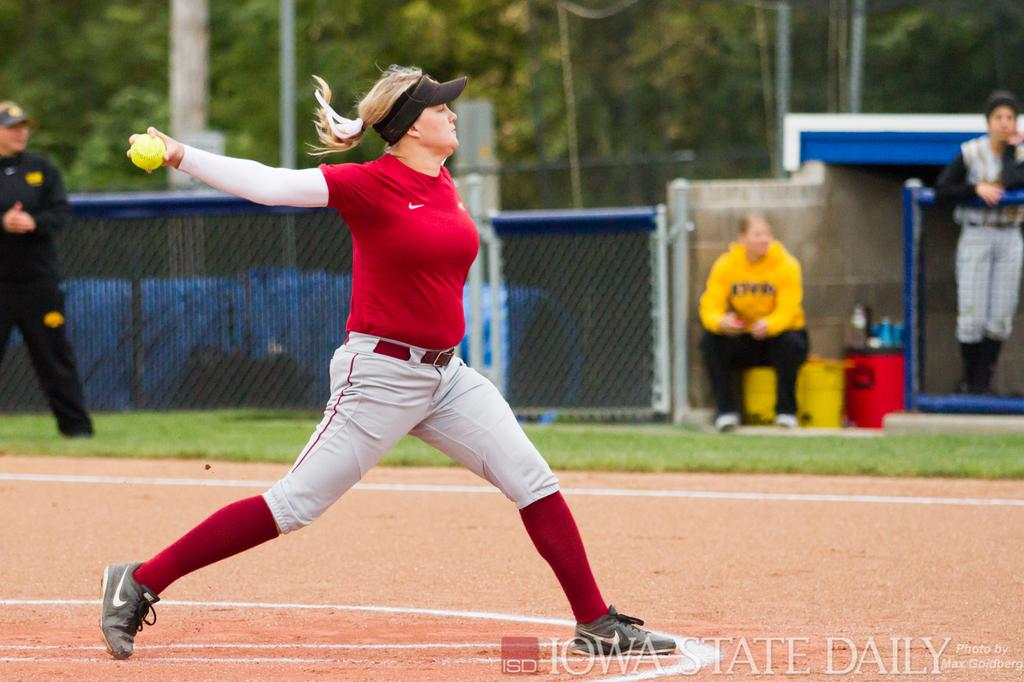Provide a one-sentence caption for the provided image. softball pitcher in red getting ready to throw photo by iowa state daily. 